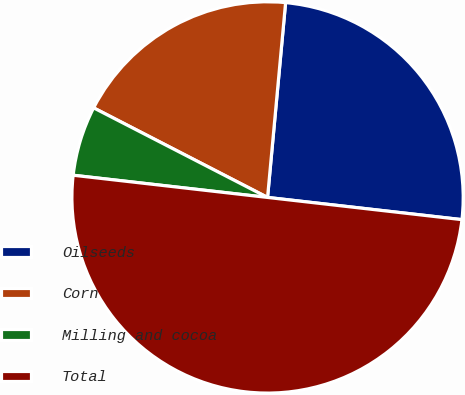<chart> <loc_0><loc_0><loc_500><loc_500><pie_chart><fcel>Oilseeds<fcel>Corn<fcel>Milling and cocoa<fcel>Total<nl><fcel>25.34%<fcel>18.9%<fcel>5.76%<fcel>50.0%<nl></chart> 